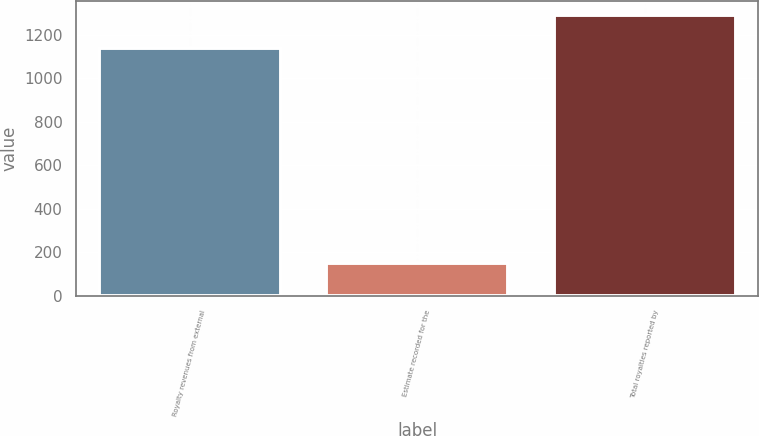<chart> <loc_0><loc_0><loc_500><loc_500><bar_chart><fcel>Royalty revenues from external<fcel>Estimate recorded for the<fcel>Total royalties reported by<nl><fcel>1141<fcel>151<fcel>1292<nl></chart> 